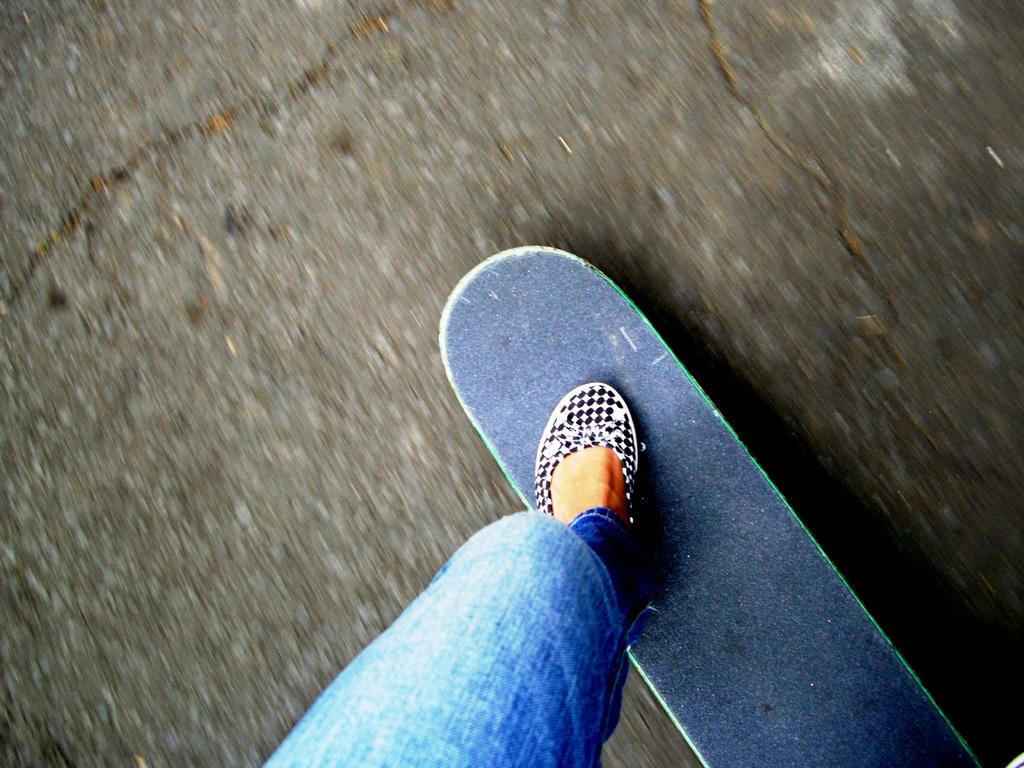What is the main subject of the image? There is a person in the image. What is the person doing in the image? The person is standing on a skateboard. What can be seen in the background of the image? There is a road visible in the image. What type of cord is being used to control the skateboard in the image? There is no cord visible in the image, and the skateboard is being controlled by the person standing on it. 